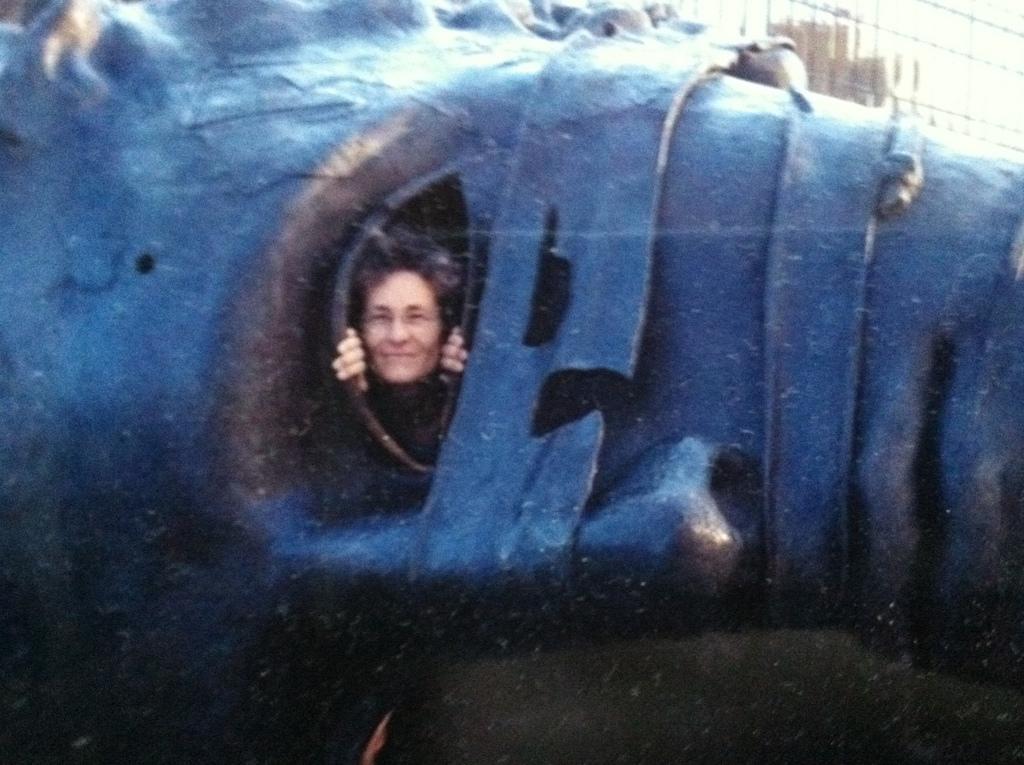Describe this image in one or two sentences. In this image we can see a sculpture, it is in blue color, where are the eyes, here is the human face, here is the nose. 